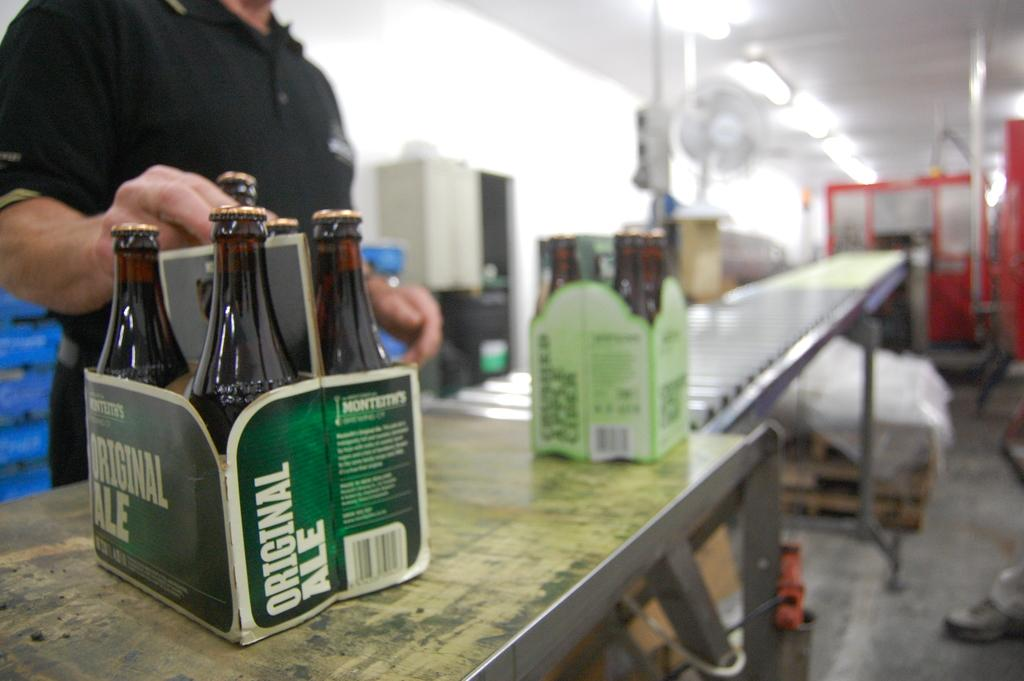<image>
Describe the image concisely. the word original that is on a case for bottles 